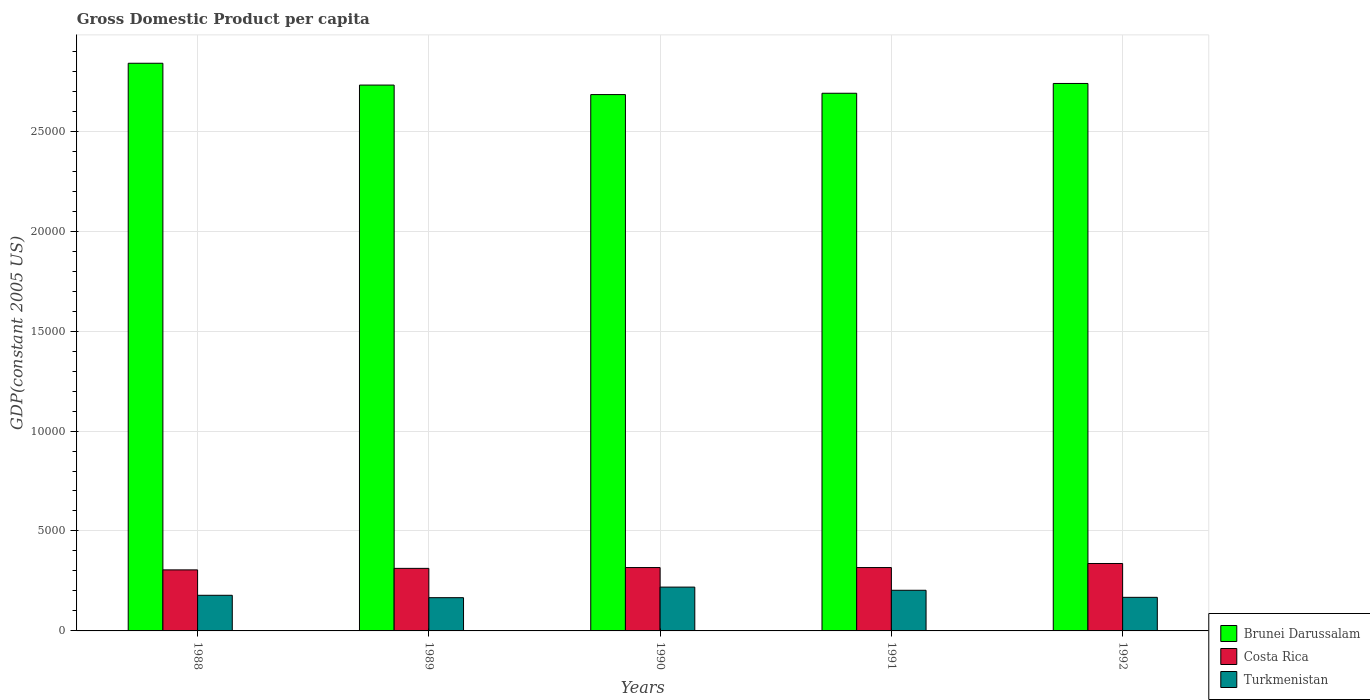How many groups of bars are there?
Your response must be concise. 5. Are the number of bars per tick equal to the number of legend labels?
Your answer should be compact. Yes. How many bars are there on the 2nd tick from the right?
Make the answer very short. 3. What is the GDP per capita in Costa Rica in 1989?
Provide a succinct answer. 3128.94. Across all years, what is the maximum GDP per capita in Brunei Darussalam?
Provide a succinct answer. 2.84e+04. Across all years, what is the minimum GDP per capita in Brunei Darussalam?
Provide a short and direct response. 2.68e+04. In which year was the GDP per capita in Costa Rica maximum?
Your response must be concise. 1992. What is the total GDP per capita in Brunei Darussalam in the graph?
Give a very brief answer. 1.37e+05. What is the difference between the GDP per capita in Brunei Darussalam in 1988 and that in 1989?
Provide a succinct answer. 1091.09. What is the difference between the GDP per capita in Turkmenistan in 1992 and the GDP per capita in Brunei Darussalam in 1989?
Offer a terse response. -2.56e+04. What is the average GDP per capita in Turkmenistan per year?
Keep it short and to the point. 1870.28. In the year 1992, what is the difference between the GDP per capita in Brunei Darussalam and GDP per capita in Costa Rica?
Provide a short and direct response. 2.40e+04. What is the ratio of the GDP per capita in Turkmenistan in 1988 to that in 1989?
Your response must be concise. 1.07. What is the difference between the highest and the second highest GDP per capita in Brunei Darussalam?
Your answer should be compact. 1010.45. What is the difference between the highest and the lowest GDP per capita in Turkmenistan?
Your response must be concise. 528.72. In how many years, is the GDP per capita in Turkmenistan greater than the average GDP per capita in Turkmenistan taken over all years?
Provide a short and direct response. 2. Is the sum of the GDP per capita in Costa Rica in 1988 and 1989 greater than the maximum GDP per capita in Brunei Darussalam across all years?
Keep it short and to the point. No. What does the 2nd bar from the left in 1990 represents?
Your response must be concise. Costa Rica. Are all the bars in the graph horizontal?
Provide a short and direct response. No. What is the difference between two consecutive major ticks on the Y-axis?
Your response must be concise. 5000. Are the values on the major ticks of Y-axis written in scientific E-notation?
Give a very brief answer. No. Does the graph contain any zero values?
Provide a succinct answer. No. What is the title of the graph?
Ensure brevity in your answer.  Gross Domestic Product per capita. Does "Caribbean small states" appear as one of the legend labels in the graph?
Make the answer very short. No. What is the label or title of the Y-axis?
Keep it short and to the point. GDP(constant 2005 US). What is the GDP(constant 2005 US) of Brunei Darussalam in 1988?
Provide a succinct answer. 2.84e+04. What is the GDP(constant 2005 US) of Costa Rica in 1988?
Your answer should be compact. 3053.32. What is the GDP(constant 2005 US) of Turkmenistan in 1988?
Make the answer very short. 1782.86. What is the GDP(constant 2005 US) of Brunei Darussalam in 1989?
Ensure brevity in your answer.  2.73e+04. What is the GDP(constant 2005 US) of Costa Rica in 1989?
Provide a succinct answer. 3128.94. What is the GDP(constant 2005 US) of Turkmenistan in 1989?
Offer a very short reply. 1663.26. What is the GDP(constant 2005 US) in Brunei Darussalam in 1990?
Make the answer very short. 2.68e+04. What is the GDP(constant 2005 US) in Costa Rica in 1990?
Your response must be concise. 3170.22. What is the GDP(constant 2005 US) of Turkmenistan in 1990?
Ensure brevity in your answer.  2191.98. What is the GDP(constant 2005 US) in Brunei Darussalam in 1991?
Keep it short and to the point. 2.69e+04. What is the GDP(constant 2005 US) in Costa Rica in 1991?
Provide a succinct answer. 3170.19. What is the GDP(constant 2005 US) of Turkmenistan in 1991?
Offer a terse response. 2033.2. What is the GDP(constant 2005 US) in Brunei Darussalam in 1992?
Your response must be concise. 2.74e+04. What is the GDP(constant 2005 US) in Costa Rica in 1992?
Give a very brief answer. 3373.42. What is the GDP(constant 2005 US) of Turkmenistan in 1992?
Make the answer very short. 1680.08. Across all years, what is the maximum GDP(constant 2005 US) of Brunei Darussalam?
Your answer should be compact. 2.84e+04. Across all years, what is the maximum GDP(constant 2005 US) of Costa Rica?
Offer a very short reply. 3373.42. Across all years, what is the maximum GDP(constant 2005 US) in Turkmenistan?
Make the answer very short. 2191.98. Across all years, what is the minimum GDP(constant 2005 US) in Brunei Darussalam?
Your response must be concise. 2.68e+04. Across all years, what is the minimum GDP(constant 2005 US) of Costa Rica?
Ensure brevity in your answer.  3053.32. Across all years, what is the minimum GDP(constant 2005 US) in Turkmenistan?
Provide a short and direct response. 1663.26. What is the total GDP(constant 2005 US) in Brunei Darussalam in the graph?
Offer a very short reply. 1.37e+05. What is the total GDP(constant 2005 US) of Costa Rica in the graph?
Provide a short and direct response. 1.59e+04. What is the total GDP(constant 2005 US) in Turkmenistan in the graph?
Your answer should be compact. 9351.39. What is the difference between the GDP(constant 2005 US) of Brunei Darussalam in 1988 and that in 1989?
Offer a very short reply. 1091.09. What is the difference between the GDP(constant 2005 US) of Costa Rica in 1988 and that in 1989?
Provide a short and direct response. -75.62. What is the difference between the GDP(constant 2005 US) in Turkmenistan in 1988 and that in 1989?
Offer a very short reply. 119.6. What is the difference between the GDP(constant 2005 US) in Brunei Darussalam in 1988 and that in 1990?
Offer a terse response. 1567.24. What is the difference between the GDP(constant 2005 US) in Costa Rica in 1988 and that in 1990?
Offer a terse response. -116.9. What is the difference between the GDP(constant 2005 US) in Turkmenistan in 1988 and that in 1990?
Offer a very short reply. -409.12. What is the difference between the GDP(constant 2005 US) of Brunei Darussalam in 1988 and that in 1991?
Keep it short and to the point. 1500.55. What is the difference between the GDP(constant 2005 US) of Costa Rica in 1988 and that in 1991?
Your response must be concise. -116.87. What is the difference between the GDP(constant 2005 US) of Turkmenistan in 1988 and that in 1991?
Offer a terse response. -250.33. What is the difference between the GDP(constant 2005 US) in Brunei Darussalam in 1988 and that in 1992?
Give a very brief answer. 1010.45. What is the difference between the GDP(constant 2005 US) of Costa Rica in 1988 and that in 1992?
Make the answer very short. -320.1. What is the difference between the GDP(constant 2005 US) in Turkmenistan in 1988 and that in 1992?
Your answer should be compact. 102.78. What is the difference between the GDP(constant 2005 US) in Brunei Darussalam in 1989 and that in 1990?
Ensure brevity in your answer.  476.14. What is the difference between the GDP(constant 2005 US) in Costa Rica in 1989 and that in 1990?
Your answer should be very brief. -41.28. What is the difference between the GDP(constant 2005 US) in Turkmenistan in 1989 and that in 1990?
Your answer should be compact. -528.72. What is the difference between the GDP(constant 2005 US) of Brunei Darussalam in 1989 and that in 1991?
Your response must be concise. 409.45. What is the difference between the GDP(constant 2005 US) in Costa Rica in 1989 and that in 1991?
Your response must be concise. -41.25. What is the difference between the GDP(constant 2005 US) in Turkmenistan in 1989 and that in 1991?
Offer a terse response. -369.93. What is the difference between the GDP(constant 2005 US) in Brunei Darussalam in 1989 and that in 1992?
Offer a very short reply. -80.65. What is the difference between the GDP(constant 2005 US) of Costa Rica in 1989 and that in 1992?
Offer a terse response. -244.48. What is the difference between the GDP(constant 2005 US) of Turkmenistan in 1989 and that in 1992?
Ensure brevity in your answer.  -16.82. What is the difference between the GDP(constant 2005 US) of Brunei Darussalam in 1990 and that in 1991?
Ensure brevity in your answer.  -66.69. What is the difference between the GDP(constant 2005 US) of Costa Rica in 1990 and that in 1991?
Your answer should be compact. 0.03. What is the difference between the GDP(constant 2005 US) of Turkmenistan in 1990 and that in 1991?
Your answer should be very brief. 158.79. What is the difference between the GDP(constant 2005 US) in Brunei Darussalam in 1990 and that in 1992?
Provide a short and direct response. -556.79. What is the difference between the GDP(constant 2005 US) in Costa Rica in 1990 and that in 1992?
Make the answer very short. -203.2. What is the difference between the GDP(constant 2005 US) of Turkmenistan in 1990 and that in 1992?
Your answer should be compact. 511.9. What is the difference between the GDP(constant 2005 US) in Brunei Darussalam in 1991 and that in 1992?
Make the answer very short. -490.1. What is the difference between the GDP(constant 2005 US) in Costa Rica in 1991 and that in 1992?
Give a very brief answer. -203.23. What is the difference between the GDP(constant 2005 US) in Turkmenistan in 1991 and that in 1992?
Keep it short and to the point. 353.11. What is the difference between the GDP(constant 2005 US) in Brunei Darussalam in 1988 and the GDP(constant 2005 US) in Costa Rica in 1989?
Your response must be concise. 2.53e+04. What is the difference between the GDP(constant 2005 US) of Brunei Darussalam in 1988 and the GDP(constant 2005 US) of Turkmenistan in 1989?
Provide a short and direct response. 2.67e+04. What is the difference between the GDP(constant 2005 US) in Costa Rica in 1988 and the GDP(constant 2005 US) in Turkmenistan in 1989?
Offer a terse response. 1390.06. What is the difference between the GDP(constant 2005 US) of Brunei Darussalam in 1988 and the GDP(constant 2005 US) of Costa Rica in 1990?
Offer a terse response. 2.52e+04. What is the difference between the GDP(constant 2005 US) of Brunei Darussalam in 1988 and the GDP(constant 2005 US) of Turkmenistan in 1990?
Offer a very short reply. 2.62e+04. What is the difference between the GDP(constant 2005 US) in Costa Rica in 1988 and the GDP(constant 2005 US) in Turkmenistan in 1990?
Provide a succinct answer. 861.34. What is the difference between the GDP(constant 2005 US) of Brunei Darussalam in 1988 and the GDP(constant 2005 US) of Costa Rica in 1991?
Your answer should be compact. 2.52e+04. What is the difference between the GDP(constant 2005 US) of Brunei Darussalam in 1988 and the GDP(constant 2005 US) of Turkmenistan in 1991?
Provide a succinct answer. 2.64e+04. What is the difference between the GDP(constant 2005 US) of Costa Rica in 1988 and the GDP(constant 2005 US) of Turkmenistan in 1991?
Make the answer very short. 1020.12. What is the difference between the GDP(constant 2005 US) of Brunei Darussalam in 1988 and the GDP(constant 2005 US) of Costa Rica in 1992?
Your answer should be very brief. 2.50e+04. What is the difference between the GDP(constant 2005 US) in Brunei Darussalam in 1988 and the GDP(constant 2005 US) in Turkmenistan in 1992?
Keep it short and to the point. 2.67e+04. What is the difference between the GDP(constant 2005 US) of Costa Rica in 1988 and the GDP(constant 2005 US) of Turkmenistan in 1992?
Provide a succinct answer. 1373.24. What is the difference between the GDP(constant 2005 US) of Brunei Darussalam in 1989 and the GDP(constant 2005 US) of Costa Rica in 1990?
Provide a succinct answer. 2.41e+04. What is the difference between the GDP(constant 2005 US) of Brunei Darussalam in 1989 and the GDP(constant 2005 US) of Turkmenistan in 1990?
Make the answer very short. 2.51e+04. What is the difference between the GDP(constant 2005 US) in Costa Rica in 1989 and the GDP(constant 2005 US) in Turkmenistan in 1990?
Your answer should be compact. 936.96. What is the difference between the GDP(constant 2005 US) of Brunei Darussalam in 1989 and the GDP(constant 2005 US) of Costa Rica in 1991?
Your response must be concise. 2.41e+04. What is the difference between the GDP(constant 2005 US) of Brunei Darussalam in 1989 and the GDP(constant 2005 US) of Turkmenistan in 1991?
Make the answer very short. 2.53e+04. What is the difference between the GDP(constant 2005 US) of Costa Rica in 1989 and the GDP(constant 2005 US) of Turkmenistan in 1991?
Offer a terse response. 1095.74. What is the difference between the GDP(constant 2005 US) in Brunei Darussalam in 1989 and the GDP(constant 2005 US) in Costa Rica in 1992?
Provide a short and direct response. 2.39e+04. What is the difference between the GDP(constant 2005 US) in Brunei Darussalam in 1989 and the GDP(constant 2005 US) in Turkmenistan in 1992?
Make the answer very short. 2.56e+04. What is the difference between the GDP(constant 2005 US) in Costa Rica in 1989 and the GDP(constant 2005 US) in Turkmenistan in 1992?
Keep it short and to the point. 1448.86. What is the difference between the GDP(constant 2005 US) of Brunei Darussalam in 1990 and the GDP(constant 2005 US) of Costa Rica in 1991?
Offer a very short reply. 2.37e+04. What is the difference between the GDP(constant 2005 US) in Brunei Darussalam in 1990 and the GDP(constant 2005 US) in Turkmenistan in 1991?
Make the answer very short. 2.48e+04. What is the difference between the GDP(constant 2005 US) in Costa Rica in 1990 and the GDP(constant 2005 US) in Turkmenistan in 1991?
Give a very brief answer. 1137.03. What is the difference between the GDP(constant 2005 US) of Brunei Darussalam in 1990 and the GDP(constant 2005 US) of Costa Rica in 1992?
Give a very brief answer. 2.35e+04. What is the difference between the GDP(constant 2005 US) in Brunei Darussalam in 1990 and the GDP(constant 2005 US) in Turkmenistan in 1992?
Your response must be concise. 2.51e+04. What is the difference between the GDP(constant 2005 US) of Costa Rica in 1990 and the GDP(constant 2005 US) of Turkmenistan in 1992?
Your response must be concise. 1490.14. What is the difference between the GDP(constant 2005 US) of Brunei Darussalam in 1991 and the GDP(constant 2005 US) of Costa Rica in 1992?
Provide a short and direct response. 2.35e+04. What is the difference between the GDP(constant 2005 US) of Brunei Darussalam in 1991 and the GDP(constant 2005 US) of Turkmenistan in 1992?
Offer a very short reply. 2.52e+04. What is the difference between the GDP(constant 2005 US) in Costa Rica in 1991 and the GDP(constant 2005 US) in Turkmenistan in 1992?
Give a very brief answer. 1490.1. What is the average GDP(constant 2005 US) in Brunei Darussalam per year?
Give a very brief answer. 2.74e+04. What is the average GDP(constant 2005 US) of Costa Rica per year?
Keep it short and to the point. 3179.22. What is the average GDP(constant 2005 US) in Turkmenistan per year?
Ensure brevity in your answer.  1870.28. In the year 1988, what is the difference between the GDP(constant 2005 US) of Brunei Darussalam and GDP(constant 2005 US) of Costa Rica?
Your answer should be compact. 2.53e+04. In the year 1988, what is the difference between the GDP(constant 2005 US) in Brunei Darussalam and GDP(constant 2005 US) in Turkmenistan?
Your answer should be very brief. 2.66e+04. In the year 1988, what is the difference between the GDP(constant 2005 US) in Costa Rica and GDP(constant 2005 US) in Turkmenistan?
Provide a succinct answer. 1270.46. In the year 1989, what is the difference between the GDP(constant 2005 US) in Brunei Darussalam and GDP(constant 2005 US) in Costa Rica?
Give a very brief answer. 2.42e+04. In the year 1989, what is the difference between the GDP(constant 2005 US) in Brunei Darussalam and GDP(constant 2005 US) in Turkmenistan?
Ensure brevity in your answer.  2.56e+04. In the year 1989, what is the difference between the GDP(constant 2005 US) of Costa Rica and GDP(constant 2005 US) of Turkmenistan?
Ensure brevity in your answer.  1465.68. In the year 1990, what is the difference between the GDP(constant 2005 US) of Brunei Darussalam and GDP(constant 2005 US) of Costa Rica?
Provide a succinct answer. 2.37e+04. In the year 1990, what is the difference between the GDP(constant 2005 US) in Brunei Darussalam and GDP(constant 2005 US) in Turkmenistan?
Keep it short and to the point. 2.46e+04. In the year 1990, what is the difference between the GDP(constant 2005 US) of Costa Rica and GDP(constant 2005 US) of Turkmenistan?
Offer a terse response. 978.24. In the year 1991, what is the difference between the GDP(constant 2005 US) in Brunei Darussalam and GDP(constant 2005 US) in Costa Rica?
Ensure brevity in your answer.  2.37e+04. In the year 1991, what is the difference between the GDP(constant 2005 US) of Brunei Darussalam and GDP(constant 2005 US) of Turkmenistan?
Keep it short and to the point. 2.49e+04. In the year 1991, what is the difference between the GDP(constant 2005 US) of Costa Rica and GDP(constant 2005 US) of Turkmenistan?
Make the answer very short. 1136.99. In the year 1992, what is the difference between the GDP(constant 2005 US) of Brunei Darussalam and GDP(constant 2005 US) of Costa Rica?
Keep it short and to the point. 2.40e+04. In the year 1992, what is the difference between the GDP(constant 2005 US) in Brunei Darussalam and GDP(constant 2005 US) in Turkmenistan?
Offer a terse response. 2.57e+04. In the year 1992, what is the difference between the GDP(constant 2005 US) of Costa Rica and GDP(constant 2005 US) of Turkmenistan?
Give a very brief answer. 1693.34. What is the ratio of the GDP(constant 2005 US) in Brunei Darussalam in 1988 to that in 1989?
Offer a very short reply. 1.04. What is the ratio of the GDP(constant 2005 US) in Costa Rica in 1988 to that in 1989?
Provide a short and direct response. 0.98. What is the ratio of the GDP(constant 2005 US) of Turkmenistan in 1988 to that in 1989?
Your answer should be very brief. 1.07. What is the ratio of the GDP(constant 2005 US) in Brunei Darussalam in 1988 to that in 1990?
Offer a very short reply. 1.06. What is the ratio of the GDP(constant 2005 US) in Costa Rica in 1988 to that in 1990?
Your answer should be compact. 0.96. What is the ratio of the GDP(constant 2005 US) of Turkmenistan in 1988 to that in 1990?
Give a very brief answer. 0.81. What is the ratio of the GDP(constant 2005 US) of Brunei Darussalam in 1988 to that in 1991?
Provide a succinct answer. 1.06. What is the ratio of the GDP(constant 2005 US) of Costa Rica in 1988 to that in 1991?
Your answer should be compact. 0.96. What is the ratio of the GDP(constant 2005 US) of Turkmenistan in 1988 to that in 1991?
Your answer should be compact. 0.88. What is the ratio of the GDP(constant 2005 US) of Brunei Darussalam in 1988 to that in 1992?
Provide a succinct answer. 1.04. What is the ratio of the GDP(constant 2005 US) in Costa Rica in 1988 to that in 1992?
Give a very brief answer. 0.91. What is the ratio of the GDP(constant 2005 US) in Turkmenistan in 1988 to that in 1992?
Your answer should be compact. 1.06. What is the ratio of the GDP(constant 2005 US) in Brunei Darussalam in 1989 to that in 1990?
Your answer should be very brief. 1.02. What is the ratio of the GDP(constant 2005 US) in Costa Rica in 1989 to that in 1990?
Offer a terse response. 0.99. What is the ratio of the GDP(constant 2005 US) of Turkmenistan in 1989 to that in 1990?
Your answer should be compact. 0.76. What is the ratio of the GDP(constant 2005 US) of Brunei Darussalam in 1989 to that in 1991?
Ensure brevity in your answer.  1.02. What is the ratio of the GDP(constant 2005 US) in Costa Rica in 1989 to that in 1991?
Keep it short and to the point. 0.99. What is the ratio of the GDP(constant 2005 US) in Turkmenistan in 1989 to that in 1991?
Your answer should be compact. 0.82. What is the ratio of the GDP(constant 2005 US) of Brunei Darussalam in 1989 to that in 1992?
Provide a short and direct response. 1. What is the ratio of the GDP(constant 2005 US) of Costa Rica in 1989 to that in 1992?
Your answer should be very brief. 0.93. What is the ratio of the GDP(constant 2005 US) in Costa Rica in 1990 to that in 1991?
Your answer should be very brief. 1. What is the ratio of the GDP(constant 2005 US) in Turkmenistan in 1990 to that in 1991?
Give a very brief answer. 1.08. What is the ratio of the GDP(constant 2005 US) in Brunei Darussalam in 1990 to that in 1992?
Provide a succinct answer. 0.98. What is the ratio of the GDP(constant 2005 US) of Costa Rica in 1990 to that in 1992?
Make the answer very short. 0.94. What is the ratio of the GDP(constant 2005 US) in Turkmenistan in 1990 to that in 1992?
Ensure brevity in your answer.  1.3. What is the ratio of the GDP(constant 2005 US) of Brunei Darussalam in 1991 to that in 1992?
Ensure brevity in your answer.  0.98. What is the ratio of the GDP(constant 2005 US) of Costa Rica in 1991 to that in 1992?
Ensure brevity in your answer.  0.94. What is the ratio of the GDP(constant 2005 US) in Turkmenistan in 1991 to that in 1992?
Your answer should be very brief. 1.21. What is the difference between the highest and the second highest GDP(constant 2005 US) in Brunei Darussalam?
Offer a terse response. 1010.45. What is the difference between the highest and the second highest GDP(constant 2005 US) in Costa Rica?
Keep it short and to the point. 203.2. What is the difference between the highest and the second highest GDP(constant 2005 US) of Turkmenistan?
Provide a succinct answer. 158.79. What is the difference between the highest and the lowest GDP(constant 2005 US) in Brunei Darussalam?
Ensure brevity in your answer.  1567.24. What is the difference between the highest and the lowest GDP(constant 2005 US) of Costa Rica?
Keep it short and to the point. 320.1. What is the difference between the highest and the lowest GDP(constant 2005 US) of Turkmenistan?
Offer a terse response. 528.72. 